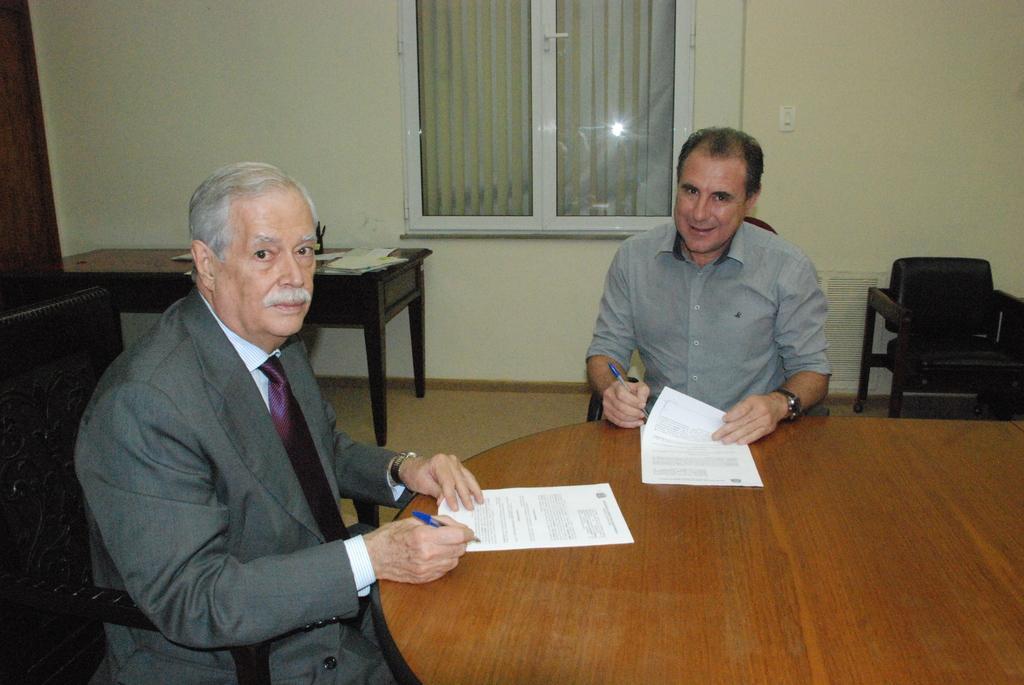Can you describe this image briefly? In the middle of the image there is a man sitting on a chair and smiling. Bottom left side of the image a man sitting on a chair and watching. Bottom right side of the image there is a table, On the table there some papers. Top right side of the image there is a wall. The top of the image there is a window. Top left side of the image there is a table. 